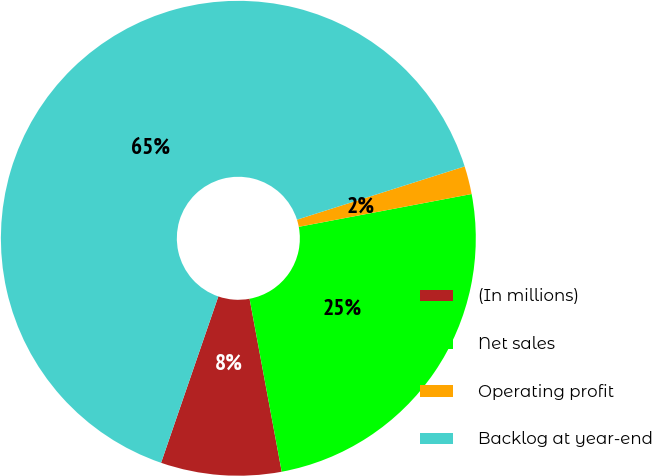Convert chart. <chart><loc_0><loc_0><loc_500><loc_500><pie_chart><fcel>(In millions)<fcel>Net sales<fcel>Operating profit<fcel>Backlog at year-end<nl><fcel>8.2%<fcel>25.06%<fcel>1.91%<fcel>64.83%<nl></chart> 